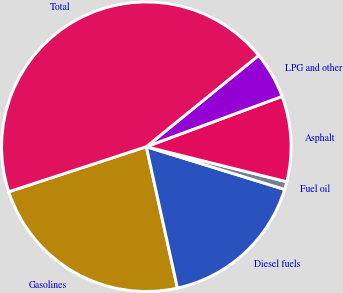<chart> <loc_0><loc_0><loc_500><loc_500><pie_chart><fcel>Gasolines<fcel>Diesel fuels<fcel>Fuel oil<fcel>Asphalt<fcel>LPG and other<fcel>Total<nl><fcel>23.41%<fcel>16.78%<fcel>0.88%<fcel>9.54%<fcel>5.21%<fcel>44.17%<nl></chart> 